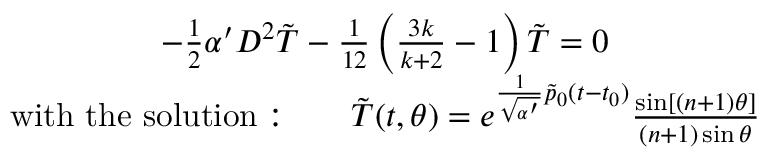<formula> <loc_0><loc_0><loc_500><loc_500>\begin{array} { c } { { - \frac { 1 } { 2 } \alpha ^ { \prime } D ^ { 2 } \tilde { T } - \frac { 1 } { 1 2 } \left ( \frac { 3 k } { k + 2 } - 1 \right ) \tilde { T } = 0 } } \\ { { w i t h t h e s o l u t i o n \colon \quad \tilde { T } ( t , \theta ) = e ^ { \frac { 1 } { \sqrt { \alpha ^ { \prime } } } \tilde { p } _ { 0 } ( t - t _ { 0 } ) } \frac { \sin [ ( n + 1 ) \theta ] } { ( n + 1 ) \sin \theta } } } \end{array}</formula> 